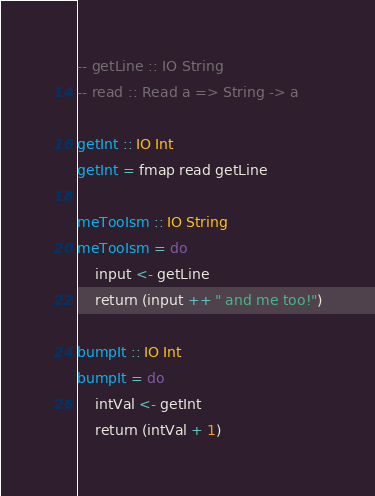Convert code to text. <code><loc_0><loc_0><loc_500><loc_500><_Haskell_>-- getLine :: IO String 
-- read :: Read a => String -> a

getInt :: IO Int 
getInt = fmap read getLine

meTooIsm :: IO String
meTooIsm = do
    input <- getLine
    return (input ++ " and me too!")

bumpIt :: IO Int
bumpIt = do
    intVal <- getInt 
    return (intVal + 1)
</code> 